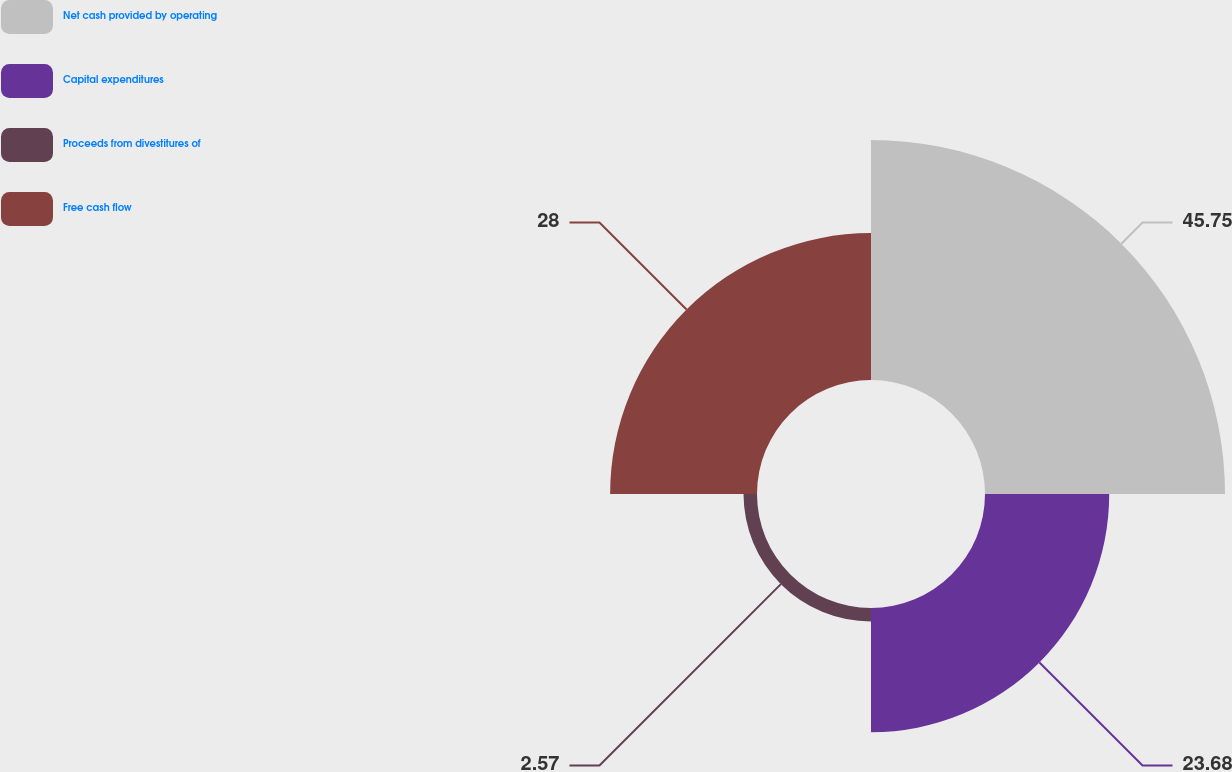Convert chart. <chart><loc_0><loc_0><loc_500><loc_500><pie_chart><fcel>Net cash provided by operating<fcel>Capital expenditures<fcel>Proceeds from divestitures of<fcel>Free cash flow<nl><fcel>45.75%<fcel>23.68%<fcel>2.57%<fcel>28.0%<nl></chart> 